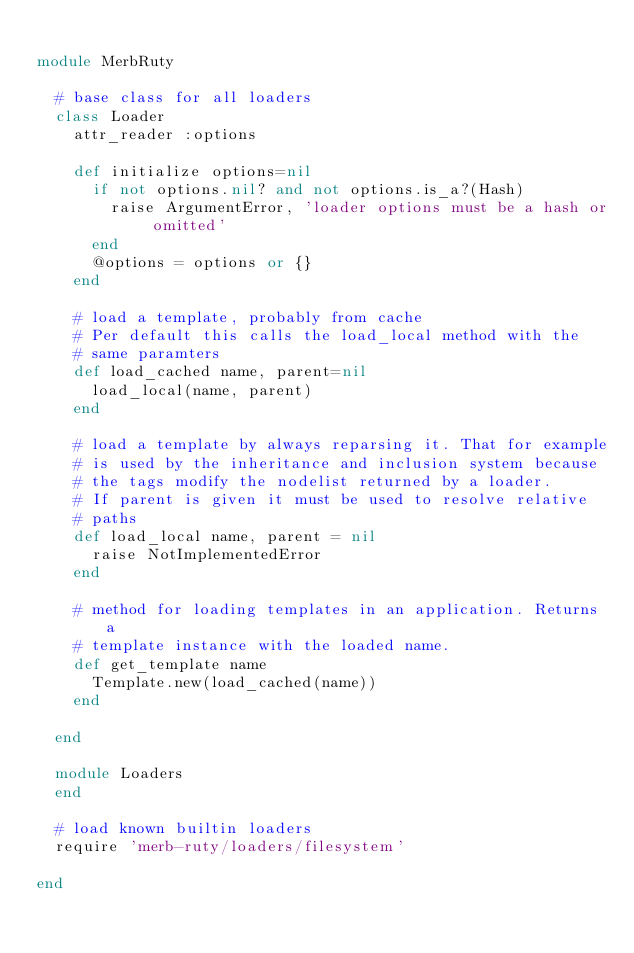Convert code to text. <code><loc_0><loc_0><loc_500><loc_500><_Ruby_>
module MerbRuty

  # base class for all loaders
  class Loader
    attr_reader :options

    def initialize options=nil
      if not options.nil? and not options.is_a?(Hash)
        raise ArgumentError, 'loader options must be a hash or omitted'
      end
      @options = options or {}
    end

    # load a template, probably from cache
    # Per default this calls the load_local method with the
    # same paramters
    def load_cached name, parent=nil
      load_local(name, parent)
    end

    # load a template by always reparsing it. That for example
    # is used by the inheritance and inclusion system because
    # the tags modify the nodelist returned by a loader.
    # If parent is given it must be used to resolve relative
    # paths
    def load_local name, parent = nil
      raise NotImplementedError
    end

    # method for loading templates in an application. Returns a
    # template instance with the loaded name.
    def get_template name
      Template.new(load_cached(name))
    end

  end

  module Loaders
  end

  # load known builtin loaders
  require 'merb-ruty/loaders/filesystem'

end
</code> 